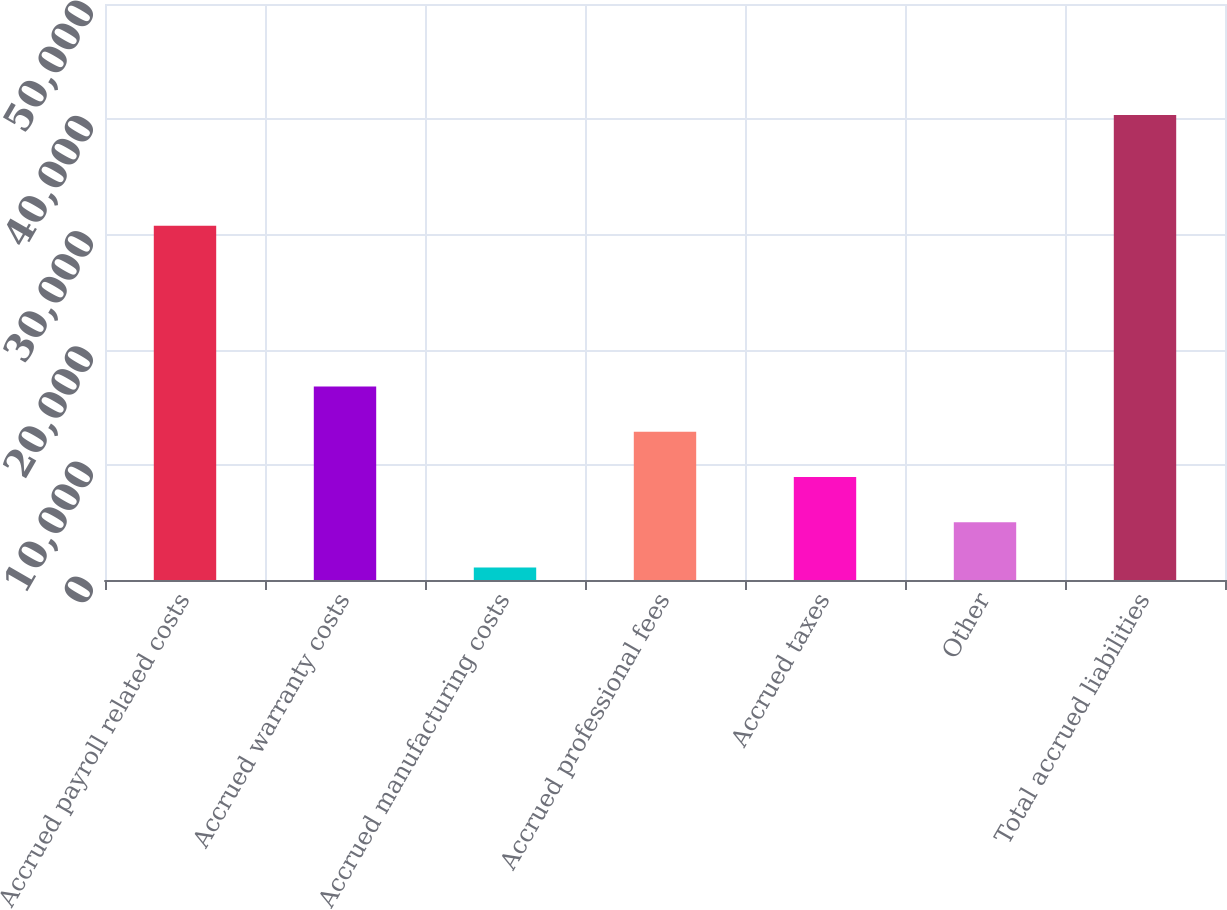Convert chart to OTSL. <chart><loc_0><loc_0><loc_500><loc_500><bar_chart><fcel>Accrued payroll related costs<fcel>Accrued warranty costs<fcel>Accrued manufacturing costs<fcel>Accrued professional fees<fcel>Accrued taxes<fcel>Other<fcel>Total accrued liabilities<nl><fcel>30749<fcel>16801<fcel>1089<fcel>12873<fcel>8945<fcel>5017<fcel>40369<nl></chart> 